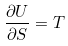<formula> <loc_0><loc_0><loc_500><loc_500>\frac { \partial U } { \partial S } = T</formula> 